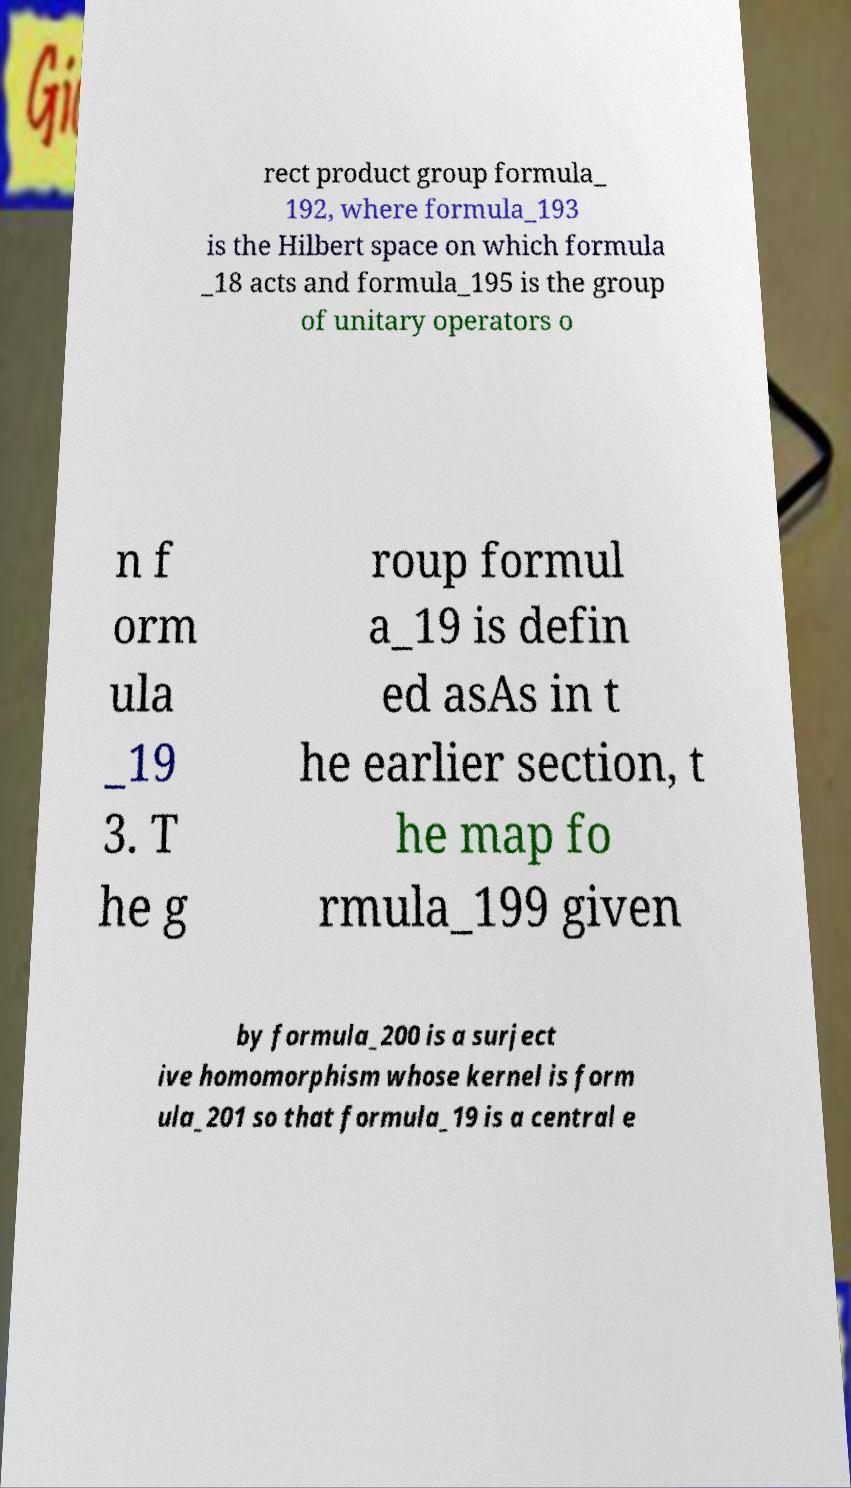Please identify and transcribe the text found in this image. rect product group formula_ 192, where formula_193 is the Hilbert space on which formula _18 acts and formula_195 is the group of unitary operators o n f orm ula _19 3. T he g roup formul a_19 is defin ed asAs in t he earlier section, t he map fo rmula_199 given by formula_200 is a surject ive homomorphism whose kernel is form ula_201 so that formula_19 is a central e 